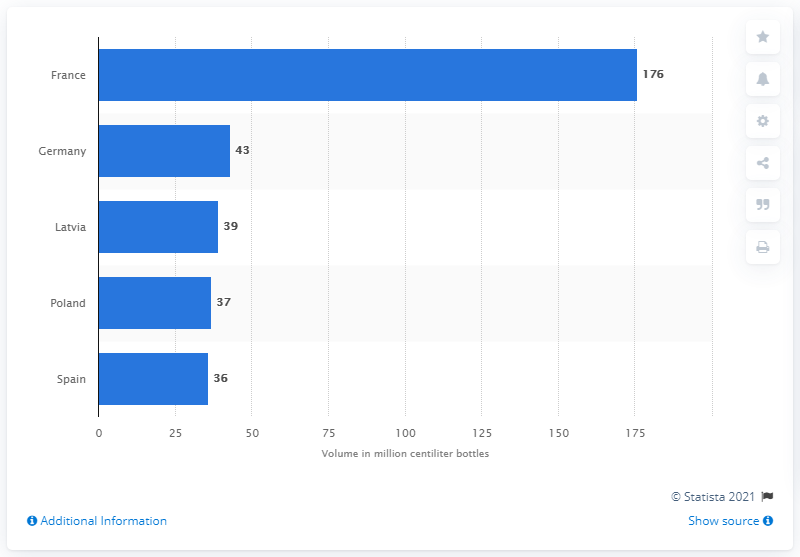Specify some key components in this picture. In 2020, France was the leading market for the export of Scotch whisky. 